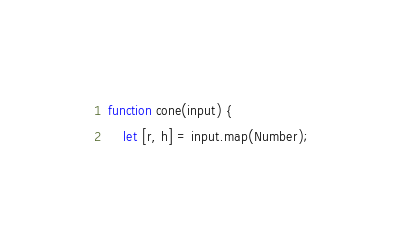<code> <loc_0><loc_0><loc_500><loc_500><_JavaScript_>function cone(input) {
    let [r, h] = input.map(Number);</code> 